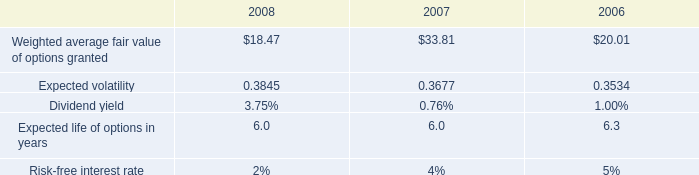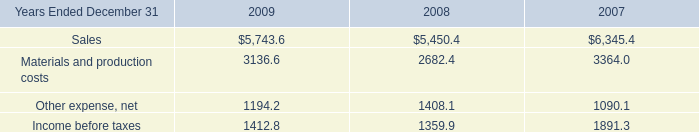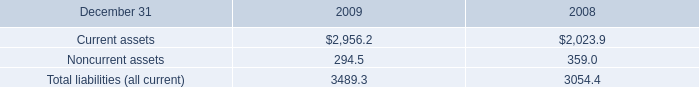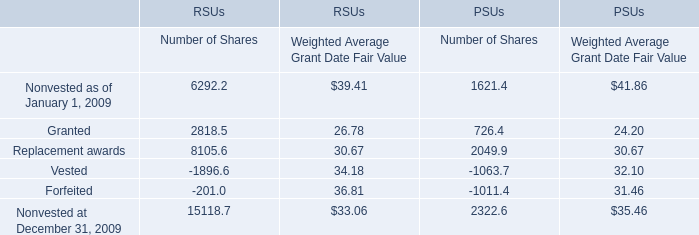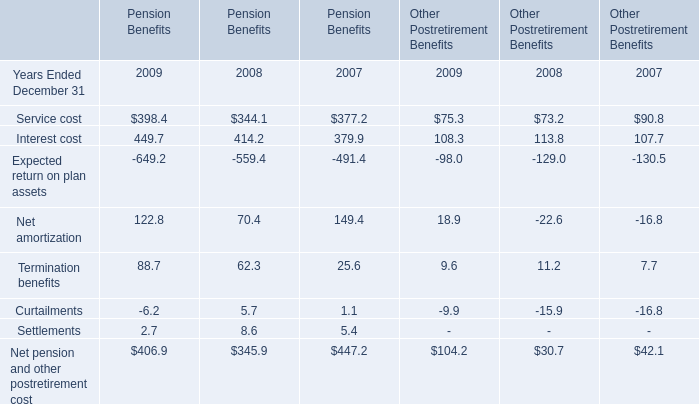What was the average value of the Vested in the year where Granted is positive? 
Computations: ((((-1896.6 + 34.18) - 1063.7) + 32.10) / 4)
Answer: -723.505. 